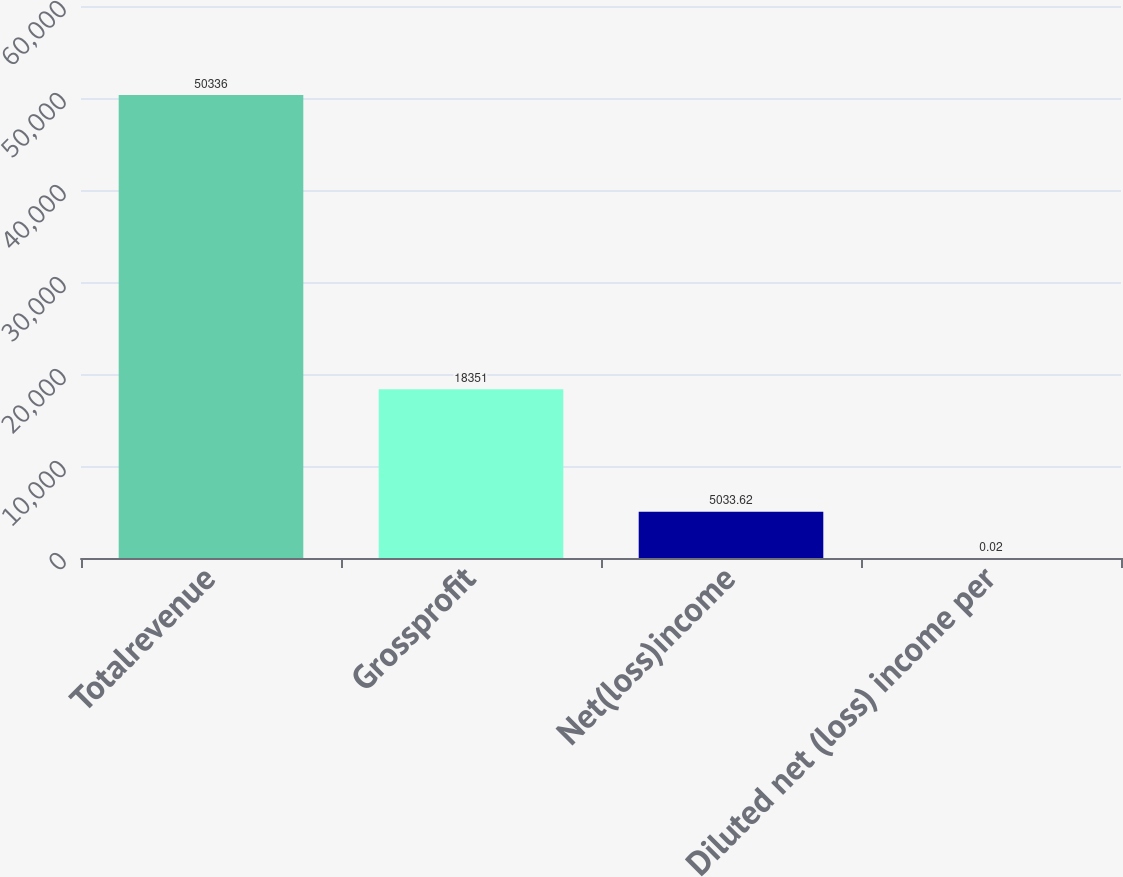<chart> <loc_0><loc_0><loc_500><loc_500><bar_chart><fcel>Totalrevenue<fcel>Grossprofit<fcel>Net(loss)income<fcel>Diluted net (loss) income per<nl><fcel>50336<fcel>18351<fcel>5033.62<fcel>0.02<nl></chart> 